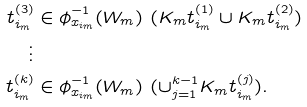<formula> <loc_0><loc_0><loc_500><loc_500>t _ { i _ { m } } ^ { ( 3 ) } & \in \phi _ { x _ { i _ { m } } } ^ { - 1 } ( W _ { m } ) \ ( K _ { m } t ^ { ( 1 ) } _ { i _ { m } } \cup K _ { m } t ^ { ( 2 ) } _ { i _ { m } } ) \\ \vdots & \\ t _ { i _ { m } } ^ { ( k ) } & \in \phi _ { x _ { i _ { m } } } ^ { - 1 } ( W _ { m } ) \ ( \cup _ { j = 1 } ^ { k - 1 } K _ { m } t ^ { ( j ) } _ { i _ { m } } ) .</formula> 